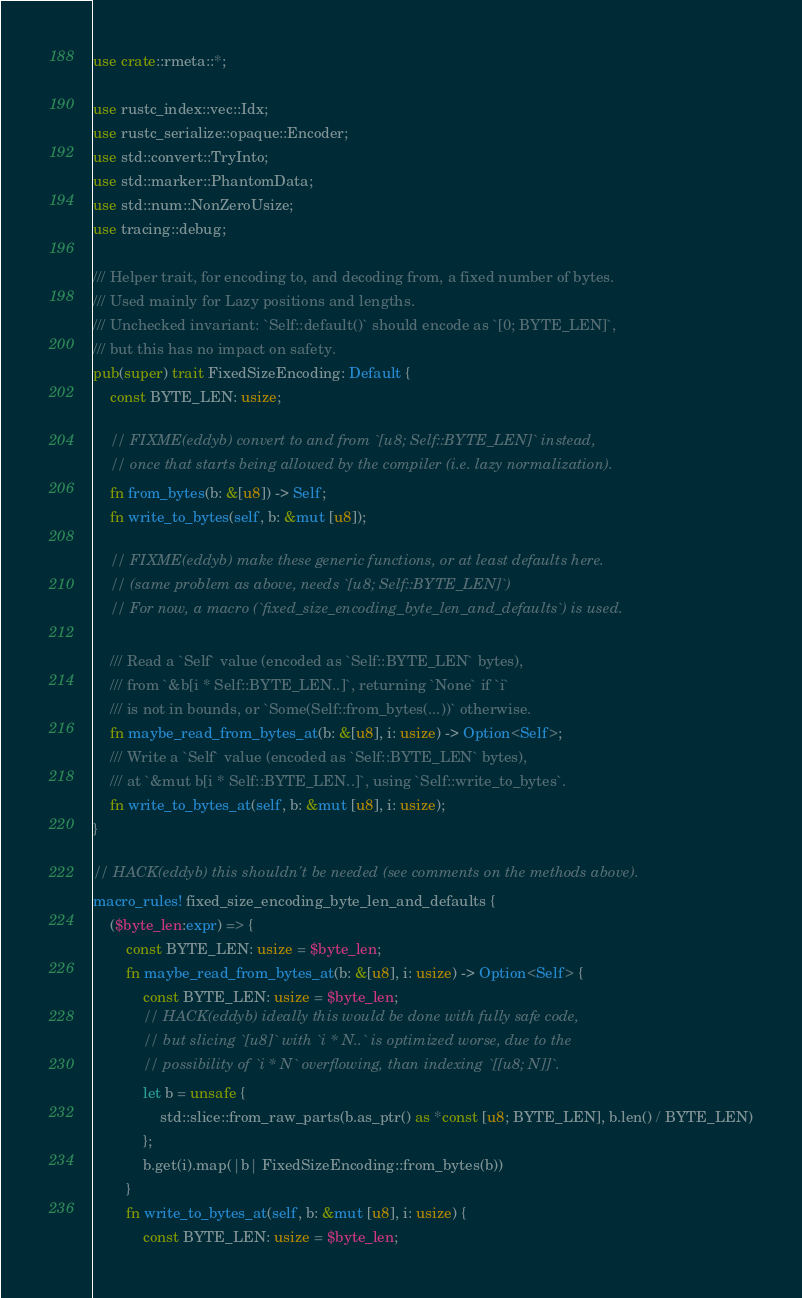Convert code to text. <code><loc_0><loc_0><loc_500><loc_500><_Rust_>use crate::rmeta::*;

use rustc_index::vec::Idx;
use rustc_serialize::opaque::Encoder;
use std::convert::TryInto;
use std::marker::PhantomData;
use std::num::NonZeroUsize;
use tracing::debug;

/// Helper trait, for encoding to, and decoding from, a fixed number of bytes.
/// Used mainly for Lazy positions and lengths.
/// Unchecked invariant: `Self::default()` should encode as `[0; BYTE_LEN]`,
/// but this has no impact on safety.
pub(super) trait FixedSizeEncoding: Default {
    const BYTE_LEN: usize;

    // FIXME(eddyb) convert to and from `[u8; Self::BYTE_LEN]` instead,
    // once that starts being allowed by the compiler (i.e. lazy normalization).
    fn from_bytes(b: &[u8]) -> Self;
    fn write_to_bytes(self, b: &mut [u8]);

    // FIXME(eddyb) make these generic functions, or at least defaults here.
    // (same problem as above, needs `[u8; Self::BYTE_LEN]`)
    // For now, a macro (`fixed_size_encoding_byte_len_and_defaults`) is used.

    /// Read a `Self` value (encoded as `Self::BYTE_LEN` bytes),
    /// from `&b[i * Self::BYTE_LEN..]`, returning `None` if `i`
    /// is not in bounds, or `Some(Self::from_bytes(...))` otherwise.
    fn maybe_read_from_bytes_at(b: &[u8], i: usize) -> Option<Self>;
    /// Write a `Self` value (encoded as `Self::BYTE_LEN` bytes),
    /// at `&mut b[i * Self::BYTE_LEN..]`, using `Self::write_to_bytes`.
    fn write_to_bytes_at(self, b: &mut [u8], i: usize);
}

// HACK(eddyb) this shouldn't be needed (see comments on the methods above).
macro_rules! fixed_size_encoding_byte_len_and_defaults {
    ($byte_len:expr) => {
        const BYTE_LEN: usize = $byte_len;
        fn maybe_read_from_bytes_at(b: &[u8], i: usize) -> Option<Self> {
            const BYTE_LEN: usize = $byte_len;
            // HACK(eddyb) ideally this would be done with fully safe code,
            // but slicing `[u8]` with `i * N..` is optimized worse, due to the
            // possibility of `i * N` overflowing, than indexing `[[u8; N]]`.
            let b = unsafe {
                std::slice::from_raw_parts(b.as_ptr() as *const [u8; BYTE_LEN], b.len() / BYTE_LEN)
            };
            b.get(i).map(|b| FixedSizeEncoding::from_bytes(b))
        }
        fn write_to_bytes_at(self, b: &mut [u8], i: usize) {
            const BYTE_LEN: usize = $byte_len;</code> 